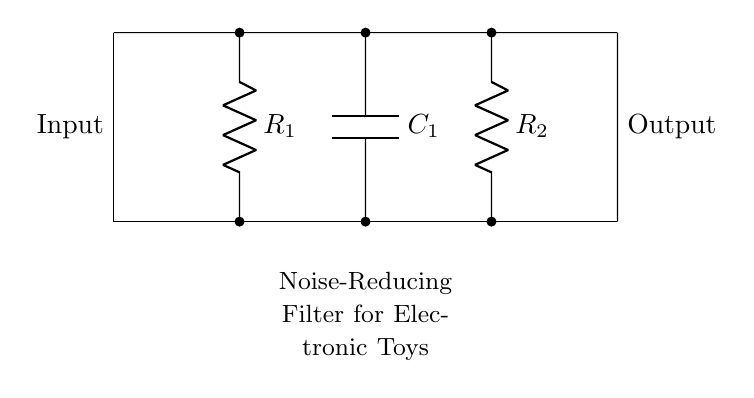What is the type of the first component? The first component in the circuit is a resistor, indicated by the symbol 'R' and labeled as 'R1'.
Answer: Resistor What does the capacitor do in this circuit? The capacitor (C1) stores and releases electrical energy, helping to reduce noise by smoothing out fluctuations in voltage.
Answer: Reduces noise How many resistors are in this circuit? There are two resistors present in the circuit, indicated as R1 and R2.
Answer: Two What is the function of the filter in your child's toy? The filter is designed to reduce noise, which enhances the audio quality of the toy and prevents distortion.
Answer: Noise reduction What is the input labeled as in the circuit? The input is labeled simply as 'Input' on the left side of the diagram.
Answer: Input What type of circuit is this? This circuit is a low-pass filter, as it primarily allows low-frequency signals to pass while attenuating higher frequencies, which contributes to noise reduction.
Answer: Low-pass filter 